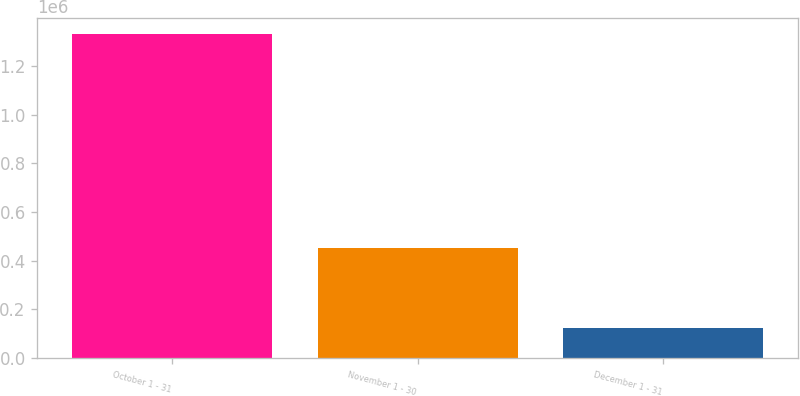Convert chart to OTSL. <chart><loc_0><loc_0><loc_500><loc_500><bar_chart><fcel>October 1 - 31<fcel>November 1 - 30<fcel>December 1 - 31<nl><fcel>1.33091e+06<fcel>452326<fcel>122326<nl></chart> 